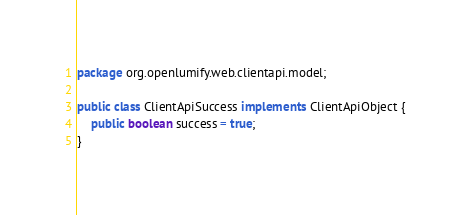<code> <loc_0><loc_0><loc_500><loc_500><_Java_>package org.openlumify.web.clientapi.model;

public class ClientApiSuccess implements ClientApiObject {
    public boolean success = true;
}
</code> 